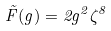<formula> <loc_0><loc_0><loc_500><loc_500>\tilde { F } ( g ) = 2 g ^ { 2 } \zeta ^ { 8 }</formula> 